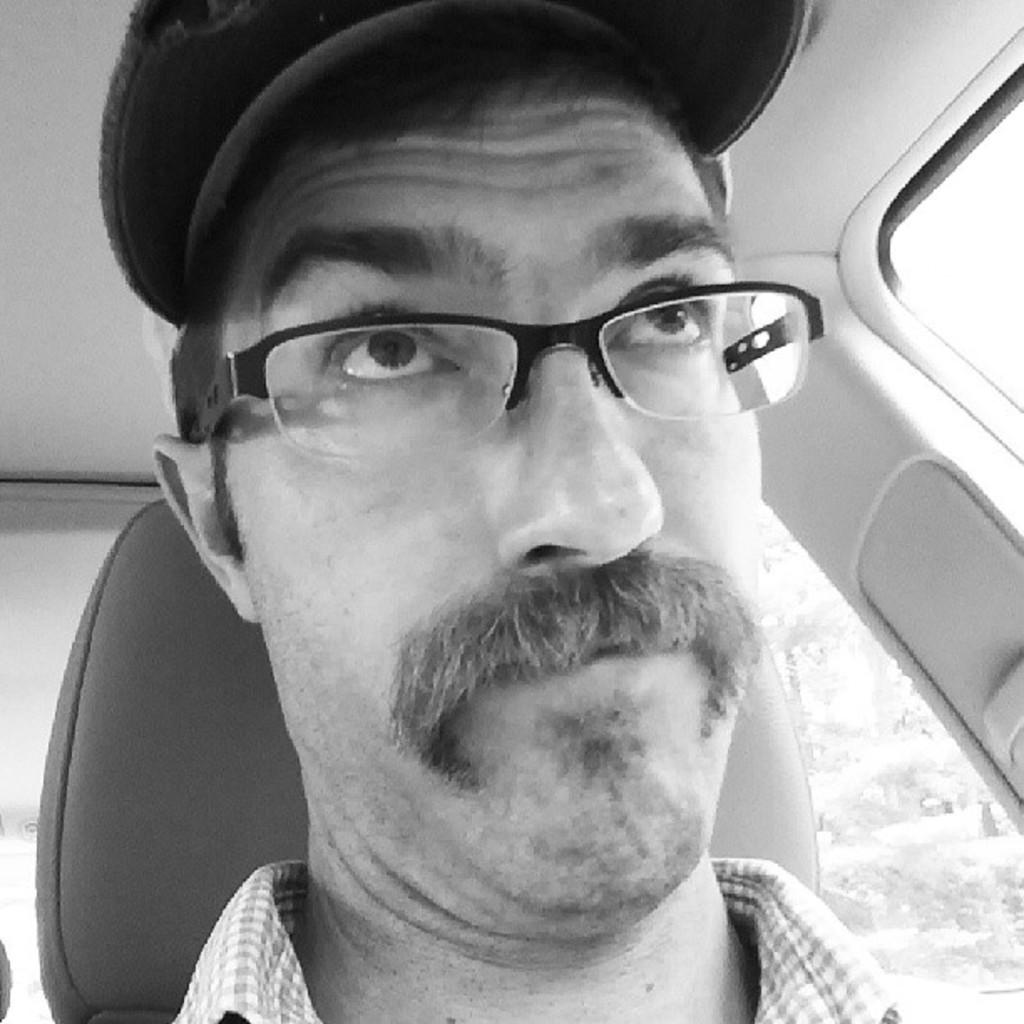Who or what is present in the image? There is a person in the image. What is the person wearing on their head? The person is wearing a cap. Where is the person located in the image? The person is sitting in a car. What type of vegetation can be seen on the right side of the image? There are trees visible on the right side of the image. What type of power does the army club have in the image? There is no army club present in the image, so it is not possible to determine the power it might have. 